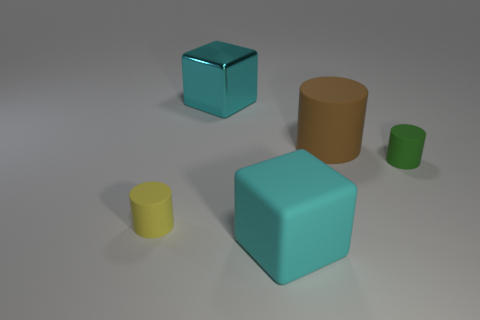There is a small object in front of the green matte object; does it have the same shape as the thing that is behind the big brown matte thing?
Make the answer very short. No. What is the size of the other cyan object that is the same shape as the large cyan metallic thing?
Keep it short and to the point. Large. What number of brown things have the same material as the small yellow thing?
Ensure brevity in your answer.  1. What material is the large brown object?
Give a very brief answer. Rubber. There is a large matte object that is behind the cylinder on the right side of the big brown matte cylinder; what is its shape?
Offer a terse response. Cylinder. There is a cyan thing behind the yellow rubber cylinder; what shape is it?
Give a very brief answer. Cube. What number of other matte cubes have the same color as the big matte block?
Keep it short and to the point. 0. What is the color of the metal thing?
Your response must be concise. Cyan. What number of big blocks are in front of the large block that is behind the tiny green matte cylinder?
Provide a short and direct response. 1. There is a cyan metallic cube; is it the same size as the matte cylinder to the left of the large brown thing?
Make the answer very short. No. 